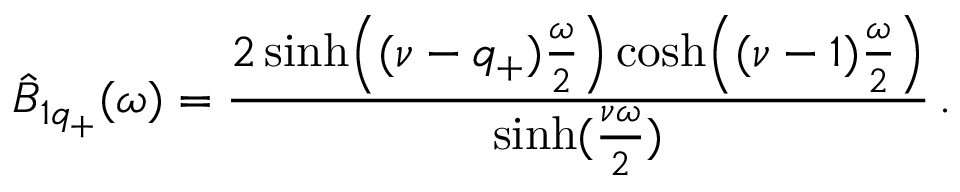Convert formula to latex. <formula><loc_0><loc_0><loc_500><loc_500>\hat { B } _ { 1 q _ { + } } ( \omega ) = { \frac { 2 \sinh \left ( ( \nu - q _ { + } ) { \frac { \omega } { 2 } } \right ) \cosh \left ( ( \nu - 1 ) { \frac { \omega } { 2 } } \right ) } { \sinh ( { \frac { \nu \omega } { 2 } } ) } } \, .</formula> 